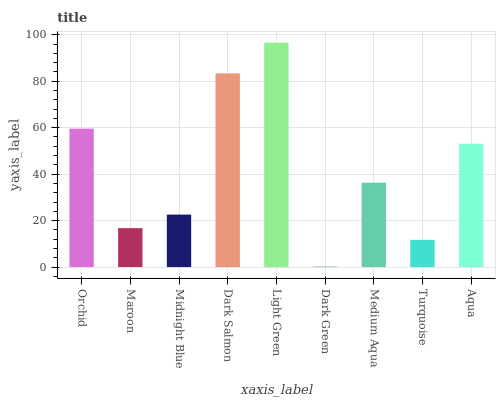Is Dark Green the minimum?
Answer yes or no. Yes. Is Light Green the maximum?
Answer yes or no. Yes. Is Maroon the minimum?
Answer yes or no. No. Is Maroon the maximum?
Answer yes or no. No. Is Orchid greater than Maroon?
Answer yes or no. Yes. Is Maroon less than Orchid?
Answer yes or no. Yes. Is Maroon greater than Orchid?
Answer yes or no. No. Is Orchid less than Maroon?
Answer yes or no. No. Is Medium Aqua the high median?
Answer yes or no. Yes. Is Medium Aqua the low median?
Answer yes or no. Yes. Is Light Green the high median?
Answer yes or no. No. Is Orchid the low median?
Answer yes or no. No. 